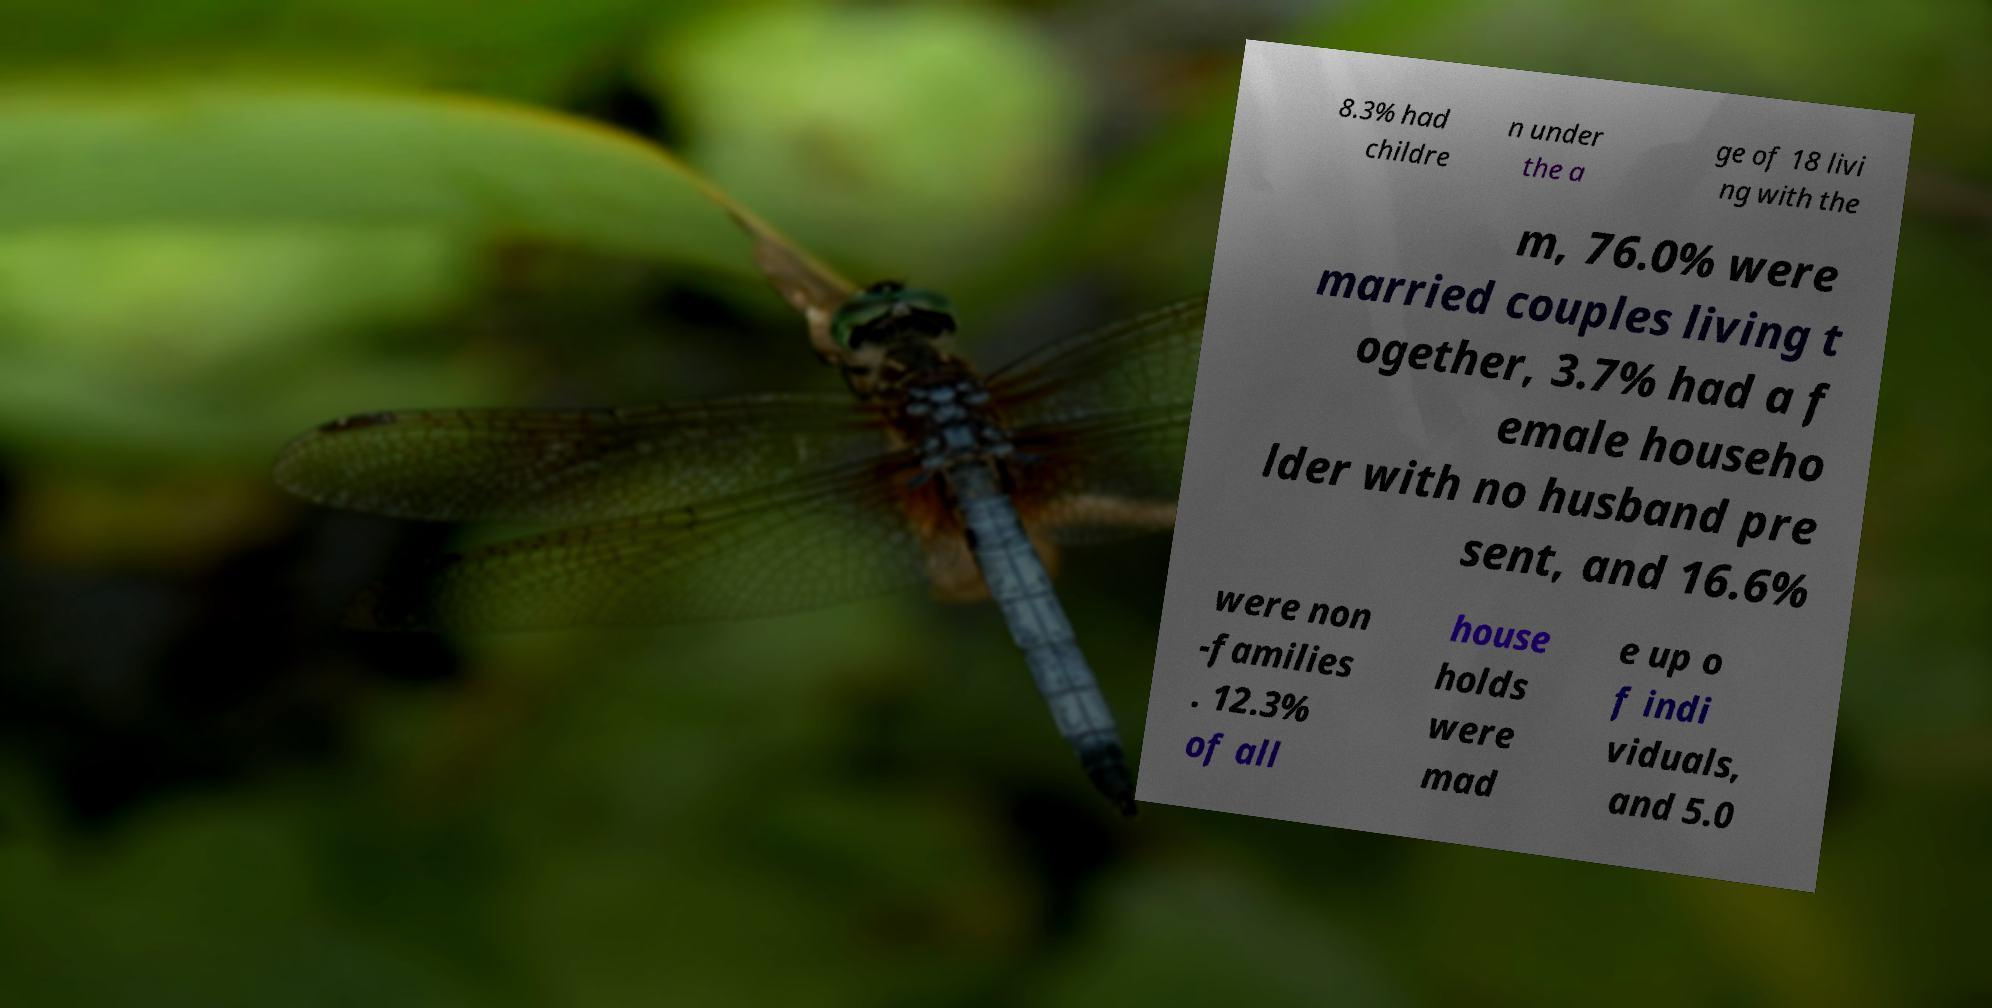Can you accurately transcribe the text from the provided image for me? 8.3% had childre n under the a ge of 18 livi ng with the m, 76.0% were married couples living t ogether, 3.7% had a f emale househo lder with no husband pre sent, and 16.6% were non -families . 12.3% of all house holds were mad e up o f indi viduals, and 5.0 